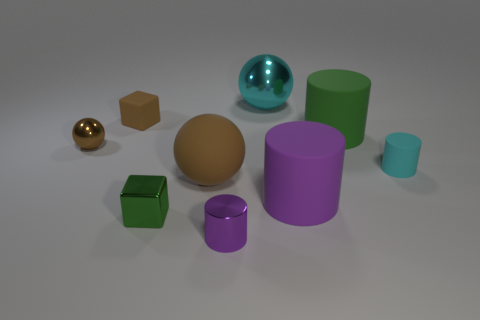Does the composition of the image suggest any particular theme or idea? The composition seems to explore the concept of diversity in unity. Although each object boasts a unique color, material, and shape, they all share the same space harmoniously. This might symbolize the beauty of various elements coming together to create a cohesive whole, which can be interpreted as a metaphor for societal diversity or the blending of different ideas and viewpoints. 